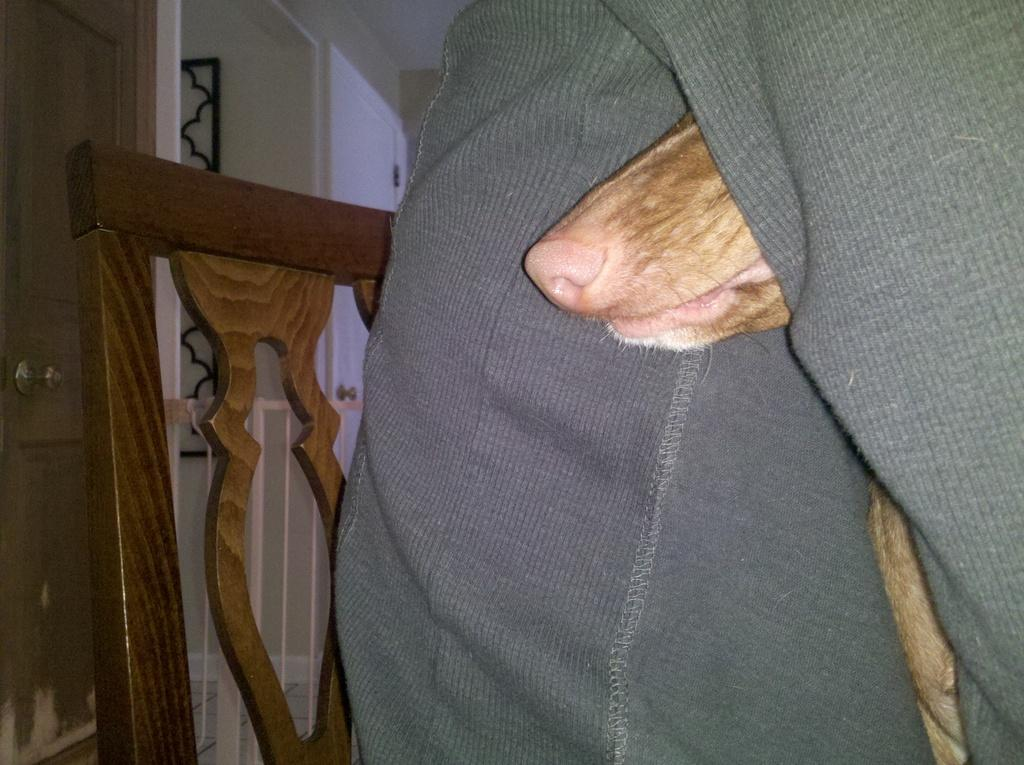What part of a dog can be seen in the image? The nose of a dog is visible in the image. Where is the dog positioned in relation to the person? The dog is standing between the legs of a person. What type of furniture is present in the image? There is a chair in the image. What is located behind the chair? There is a door visible behind the chair. What type of hands can be seen holding the dog in the image? There are no hands visible in the image; only the dog's nose and its position between the person's legs are shown. 